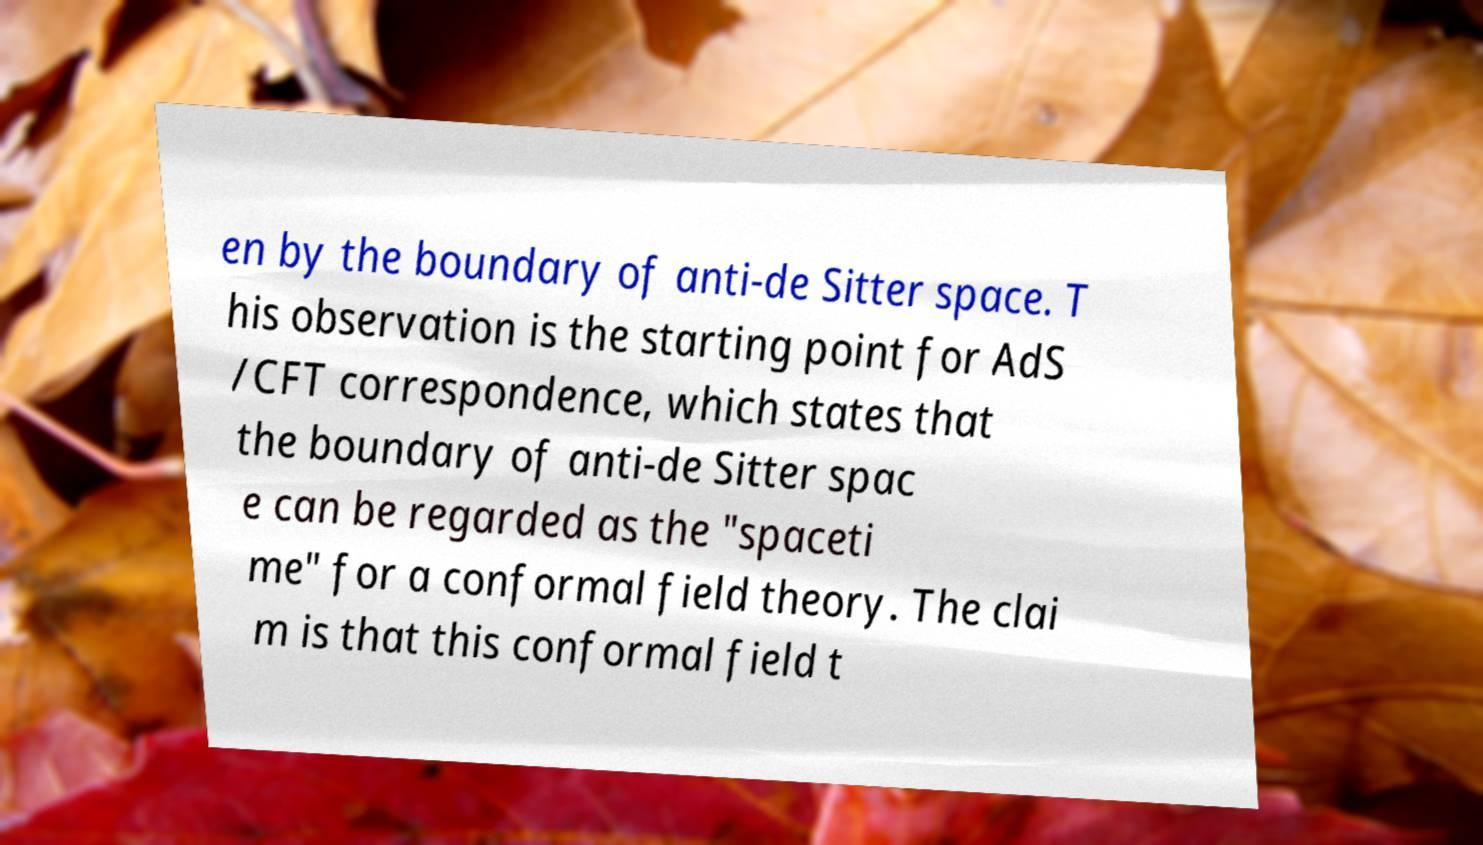What messages or text are displayed in this image? I need them in a readable, typed format. en by the boundary of anti-de Sitter space. T his observation is the starting point for AdS /CFT correspondence, which states that the boundary of anti-de Sitter spac e can be regarded as the "spaceti me" for a conformal field theory. The clai m is that this conformal field t 